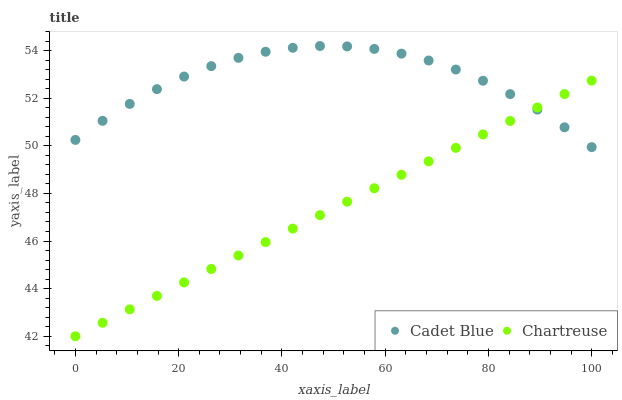Does Chartreuse have the minimum area under the curve?
Answer yes or no. Yes. Does Cadet Blue have the maximum area under the curve?
Answer yes or no. Yes. Does Cadet Blue have the minimum area under the curve?
Answer yes or no. No. Is Chartreuse the smoothest?
Answer yes or no. Yes. Is Cadet Blue the roughest?
Answer yes or no. Yes. Is Cadet Blue the smoothest?
Answer yes or no. No. Does Chartreuse have the lowest value?
Answer yes or no. Yes. Does Cadet Blue have the lowest value?
Answer yes or no. No. Does Cadet Blue have the highest value?
Answer yes or no. Yes. Does Cadet Blue intersect Chartreuse?
Answer yes or no. Yes. Is Cadet Blue less than Chartreuse?
Answer yes or no. No. Is Cadet Blue greater than Chartreuse?
Answer yes or no. No. 